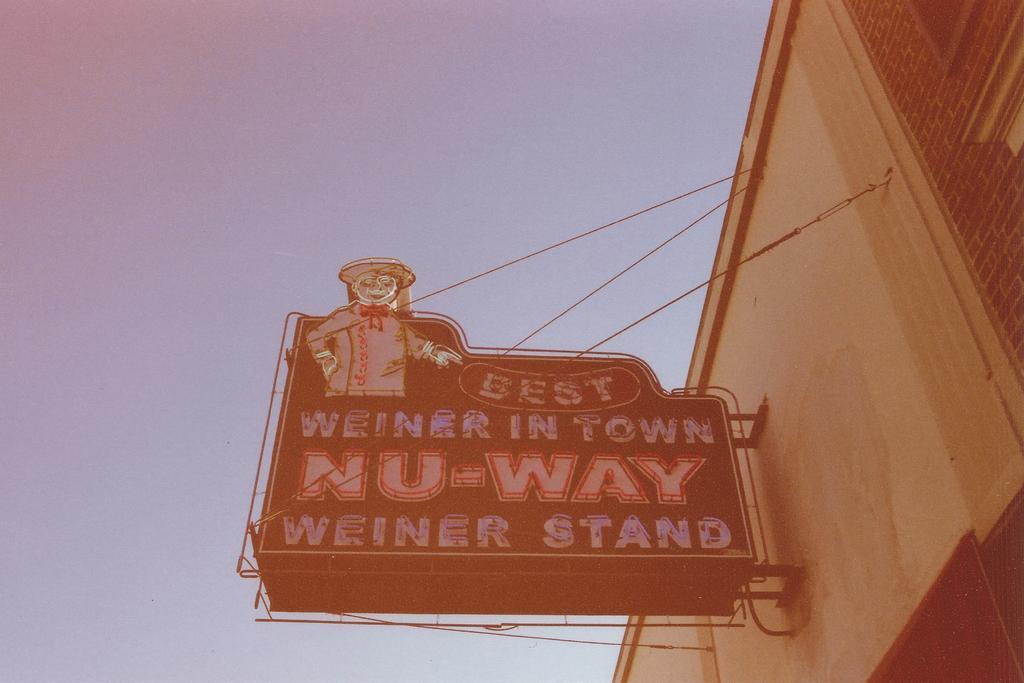In one or two sentences, can you explain what this image depicts? On the right side there is a building and I can see a board is attached the wall. On the board I can see some text. In the background, I can see the sky. 